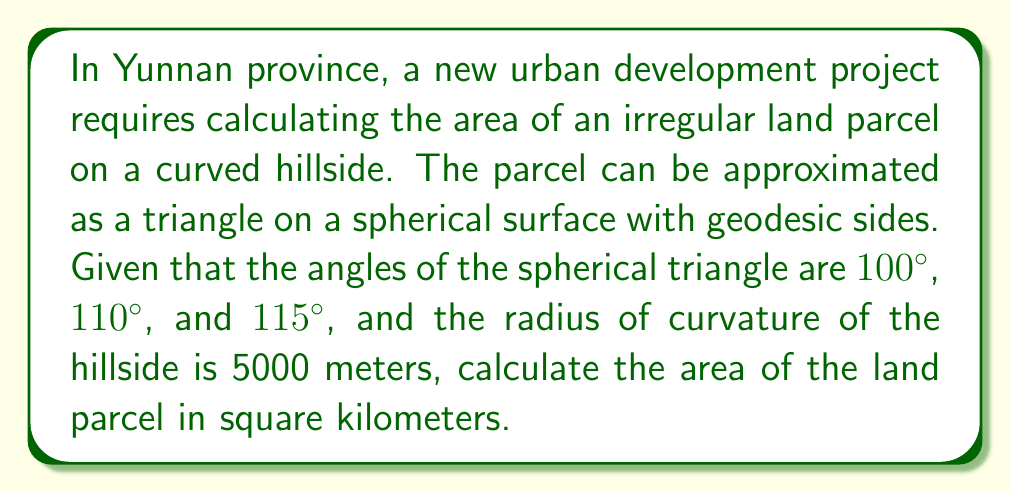Solve this math problem. To solve this problem, we'll use the formula for the area of a spherical triangle:

1) The area $A$ of a spherical triangle is given by the formula:
   $$A = R^2 (\alpha + \beta + \gamma - \pi)$$
   where $R$ is the radius of the sphere, and $\alpha$, $\beta$, and $\gamma$ are the angles of the triangle in radians.

2) Convert the given angles from degrees to radians:
   $$\alpha = 100° \cdot \frac{\pi}{180°} = \frac{5\pi}{9} \text{ rad}$$
   $$\beta = 110° \cdot \frac{\pi}{180°} = \frac{11\pi}{18} \text{ rad}$$
   $$\gamma = 115° \cdot \frac{\pi}{180°} = \frac{23\pi}{36} \text{ rad}$$

3) Sum the angles:
   $$\alpha + \beta + \gamma = \frac{5\pi}{9} + \frac{11\pi}{18} + \frac{23\pi}{36} = \frac{180\pi}{108} = \frac{5\pi}{3}$$

4) Subtract $\pi$ from the sum:
   $$\frac{5\pi}{3} - \pi = \frac{2\pi}{3}$$

5) Apply the formula with $R = 5000$ meters:
   $$A = (5000 \text{ m})^2 \cdot \frac{2\pi}{3} = \frac{50000000\pi}{3} \text{ m}^2$$

6) Convert to square kilometers:
   $$A = \frac{50000000\pi}{3} \cdot \frac{1 \text{ km}^2}{1000000 \text{ m}^2} = \frac{50\pi}{3} \text{ km}^2$$

7) Calculate the final result:
   $$A \approx 52.36 \text{ km}^2$$
Answer: 52.36 km² 